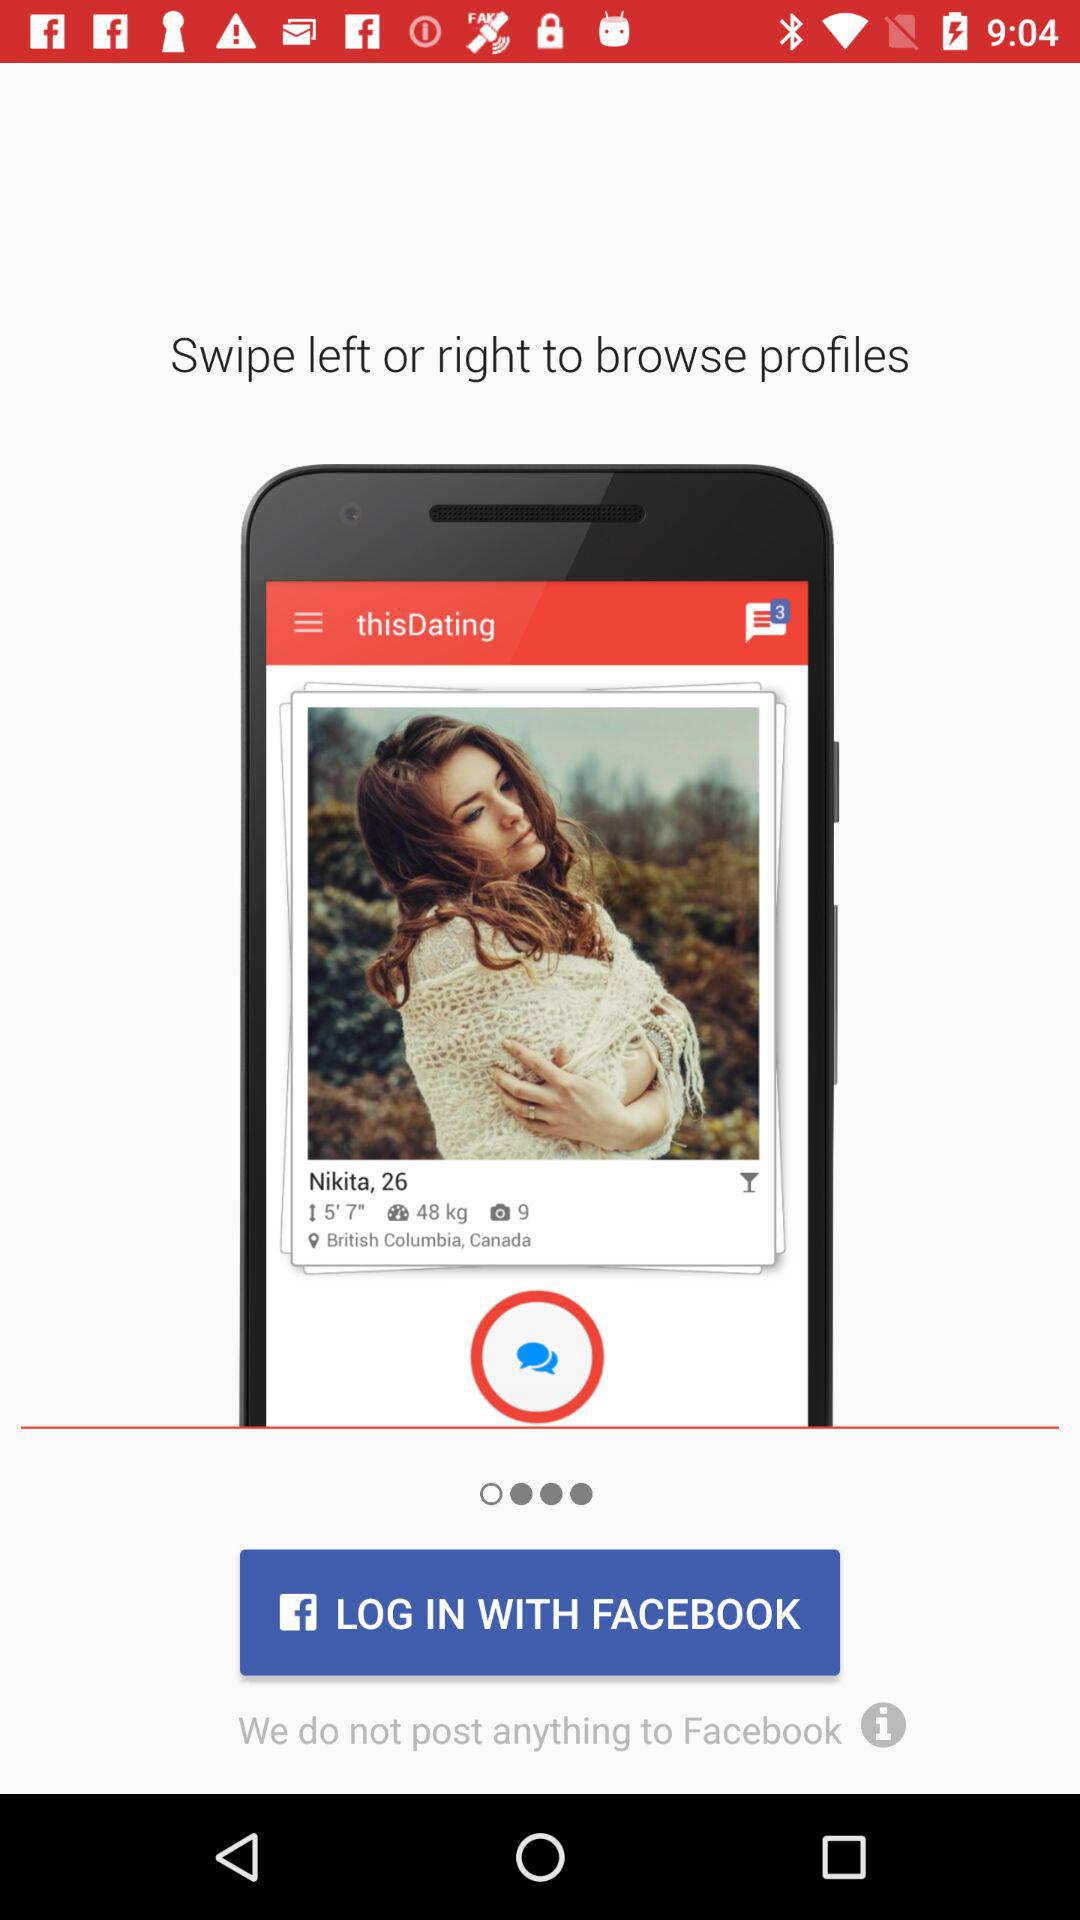Where to swipe to browse profiles? To browse profiles, swipe left or right. 